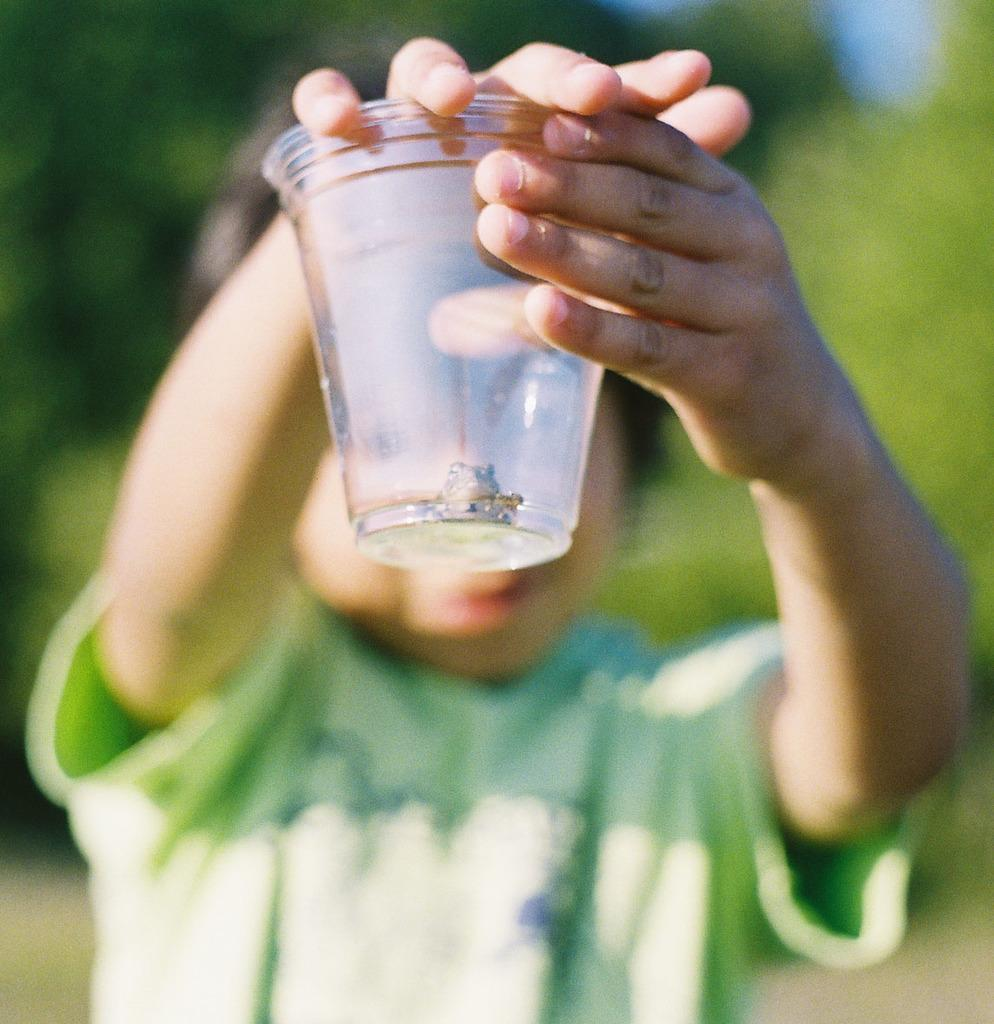Who is the main subject in the image? There is a boy in the image. What is the boy holding in his hands? The boy is holding a glass in his hands. What is the boy wearing in the image? The boy is wearing a green color t-shirt. What can be seen in the background of the image? There are trees visible in the background of the image. Can you tell me how many frogs are sitting on the boy's shoulder in the image? There are no frogs present in the image, so it is not possible to determine how many frogs might be sitting on the boy's shoulder. 